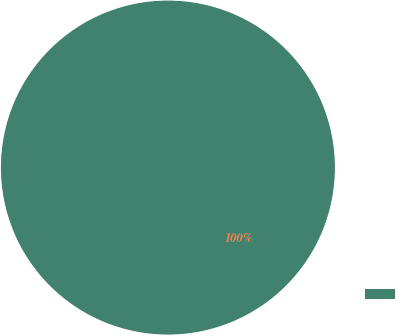<chart> <loc_0><loc_0><loc_500><loc_500><pie_chart><ecel><nl><fcel>100.0%<nl></chart> 